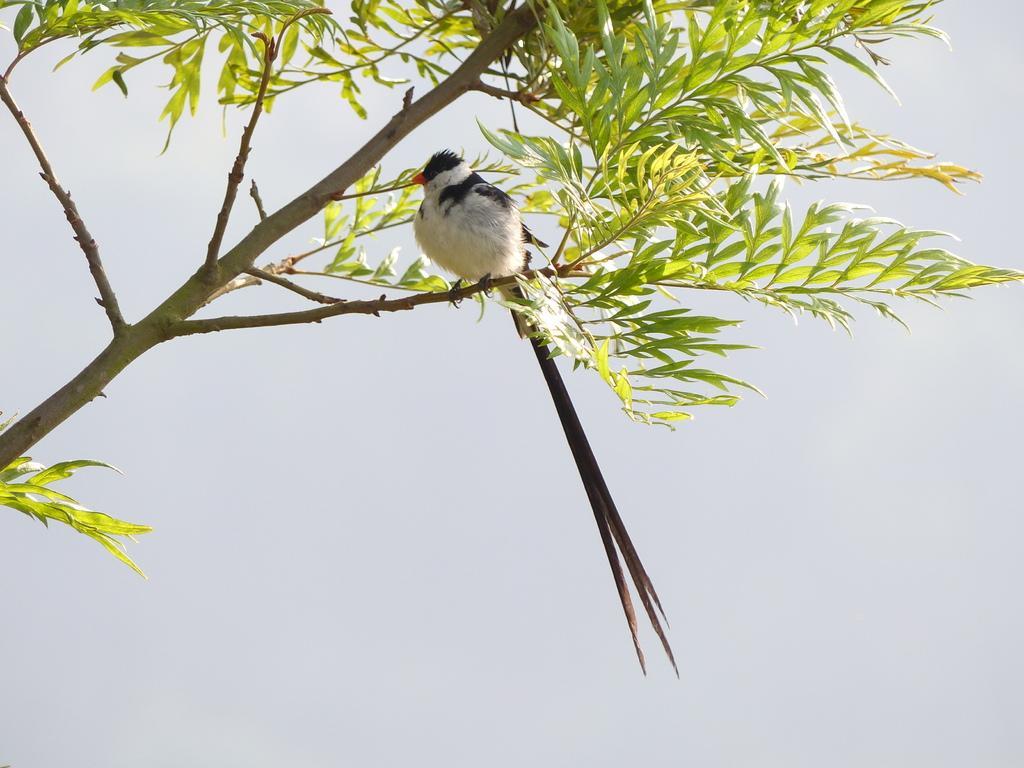Describe this image in one or two sentences. In this picture I can see a bird standing on the branch of the tree, and there is white background. 